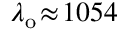Convert formula to latex. <formula><loc_0><loc_0><loc_500><loc_500>\lambda _ { o } \, \approx \, 1 0 5 4</formula> 